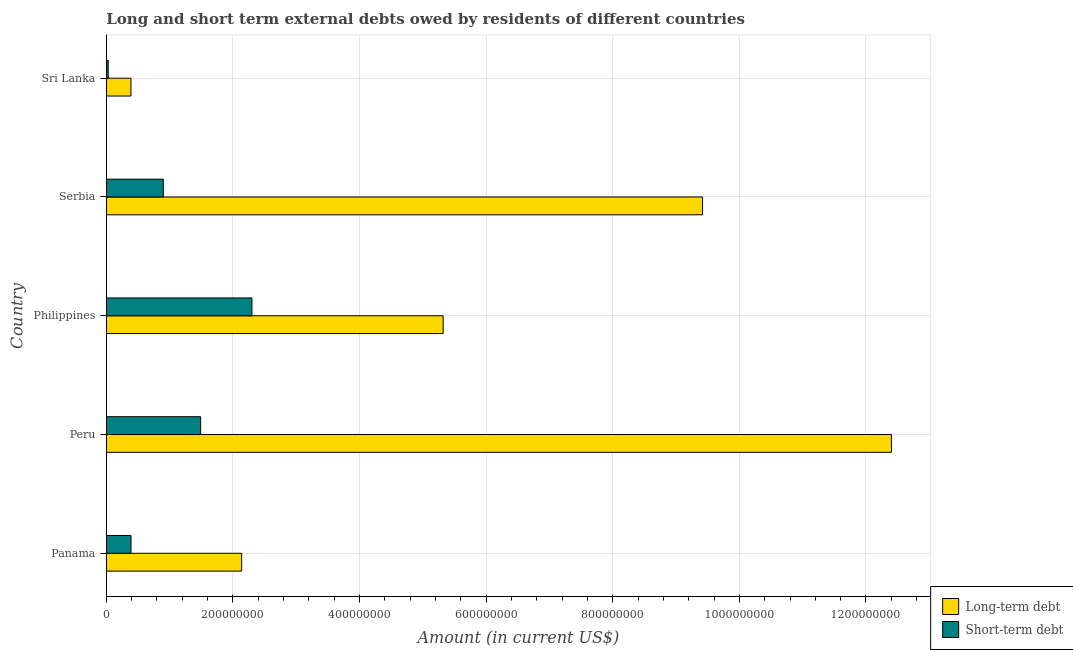How many groups of bars are there?
Your response must be concise. 5. How many bars are there on the 4th tick from the top?
Ensure brevity in your answer.  2. How many bars are there on the 1st tick from the bottom?
Offer a very short reply. 2. What is the label of the 1st group of bars from the top?
Give a very brief answer. Sri Lanka. In how many cases, is the number of bars for a given country not equal to the number of legend labels?
Provide a succinct answer. 0. What is the long-term debts owed by residents in Serbia?
Ensure brevity in your answer.  9.42e+08. Across all countries, what is the maximum long-term debts owed by residents?
Provide a short and direct response. 1.24e+09. Across all countries, what is the minimum long-term debts owed by residents?
Your answer should be very brief. 3.89e+07. In which country was the short-term debts owed by residents minimum?
Give a very brief answer. Sri Lanka. What is the total short-term debts owed by residents in the graph?
Give a very brief answer. 5.11e+08. What is the difference between the long-term debts owed by residents in Panama and that in Philippines?
Your answer should be very brief. -3.18e+08. What is the difference between the long-term debts owed by residents in Panama and the short-term debts owed by residents in Philippines?
Your answer should be very brief. -1.63e+07. What is the average short-term debts owed by residents per country?
Provide a succinct answer. 1.02e+08. What is the difference between the long-term debts owed by residents and short-term debts owed by residents in Philippines?
Provide a succinct answer. 3.02e+08. What is the ratio of the long-term debts owed by residents in Philippines to that in Serbia?
Keep it short and to the point. 0.56. What is the difference between the highest and the second highest long-term debts owed by residents?
Keep it short and to the point. 2.98e+08. What is the difference between the highest and the lowest short-term debts owed by residents?
Provide a succinct answer. 2.27e+08. In how many countries, is the long-term debts owed by residents greater than the average long-term debts owed by residents taken over all countries?
Provide a succinct answer. 2. Is the sum of the short-term debts owed by residents in Peru and Philippines greater than the maximum long-term debts owed by residents across all countries?
Make the answer very short. No. What does the 1st bar from the top in Sri Lanka represents?
Ensure brevity in your answer.  Short-term debt. What does the 2nd bar from the bottom in Panama represents?
Ensure brevity in your answer.  Short-term debt. Are all the bars in the graph horizontal?
Provide a succinct answer. Yes. How many countries are there in the graph?
Offer a terse response. 5. Are the values on the major ticks of X-axis written in scientific E-notation?
Keep it short and to the point. No. Does the graph contain grids?
Your response must be concise. Yes. How are the legend labels stacked?
Offer a very short reply. Vertical. What is the title of the graph?
Your answer should be very brief. Long and short term external debts owed by residents of different countries. What is the Amount (in current US$) in Long-term debt in Panama?
Your answer should be compact. 2.14e+08. What is the Amount (in current US$) of Short-term debt in Panama?
Your answer should be very brief. 3.90e+07. What is the Amount (in current US$) in Long-term debt in Peru?
Give a very brief answer. 1.24e+09. What is the Amount (in current US$) of Short-term debt in Peru?
Your answer should be very brief. 1.49e+08. What is the Amount (in current US$) of Long-term debt in Philippines?
Ensure brevity in your answer.  5.32e+08. What is the Amount (in current US$) in Short-term debt in Philippines?
Your response must be concise. 2.30e+08. What is the Amount (in current US$) in Long-term debt in Serbia?
Offer a very short reply. 9.42e+08. What is the Amount (in current US$) of Short-term debt in Serbia?
Your response must be concise. 9.00e+07. What is the Amount (in current US$) in Long-term debt in Sri Lanka?
Your response must be concise. 3.89e+07. What is the Amount (in current US$) in Short-term debt in Sri Lanka?
Make the answer very short. 3.00e+06. Across all countries, what is the maximum Amount (in current US$) of Long-term debt?
Your answer should be very brief. 1.24e+09. Across all countries, what is the maximum Amount (in current US$) of Short-term debt?
Give a very brief answer. 2.30e+08. Across all countries, what is the minimum Amount (in current US$) of Long-term debt?
Make the answer very short. 3.89e+07. Across all countries, what is the minimum Amount (in current US$) of Short-term debt?
Ensure brevity in your answer.  3.00e+06. What is the total Amount (in current US$) in Long-term debt in the graph?
Your response must be concise. 2.97e+09. What is the total Amount (in current US$) in Short-term debt in the graph?
Your answer should be compact. 5.11e+08. What is the difference between the Amount (in current US$) of Long-term debt in Panama and that in Peru?
Make the answer very short. -1.03e+09. What is the difference between the Amount (in current US$) in Short-term debt in Panama and that in Peru?
Your answer should be very brief. -1.10e+08. What is the difference between the Amount (in current US$) of Long-term debt in Panama and that in Philippines?
Your response must be concise. -3.18e+08. What is the difference between the Amount (in current US$) in Short-term debt in Panama and that in Philippines?
Provide a short and direct response. -1.91e+08. What is the difference between the Amount (in current US$) of Long-term debt in Panama and that in Serbia?
Provide a succinct answer. -7.28e+08. What is the difference between the Amount (in current US$) in Short-term debt in Panama and that in Serbia?
Keep it short and to the point. -5.10e+07. What is the difference between the Amount (in current US$) in Long-term debt in Panama and that in Sri Lanka?
Keep it short and to the point. 1.75e+08. What is the difference between the Amount (in current US$) in Short-term debt in Panama and that in Sri Lanka?
Your answer should be compact. 3.60e+07. What is the difference between the Amount (in current US$) of Long-term debt in Peru and that in Philippines?
Make the answer very short. 7.08e+08. What is the difference between the Amount (in current US$) in Short-term debt in Peru and that in Philippines?
Provide a succinct answer. -8.10e+07. What is the difference between the Amount (in current US$) in Long-term debt in Peru and that in Serbia?
Provide a succinct answer. 2.98e+08. What is the difference between the Amount (in current US$) in Short-term debt in Peru and that in Serbia?
Keep it short and to the point. 5.90e+07. What is the difference between the Amount (in current US$) of Long-term debt in Peru and that in Sri Lanka?
Make the answer very short. 1.20e+09. What is the difference between the Amount (in current US$) in Short-term debt in Peru and that in Sri Lanka?
Make the answer very short. 1.46e+08. What is the difference between the Amount (in current US$) of Long-term debt in Philippines and that in Serbia?
Your answer should be very brief. -4.10e+08. What is the difference between the Amount (in current US$) in Short-term debt in Philippines and that in Serbia?
Offer a terse response. 1.40e+08. What is the difference between the Amount (in current US$) of Long-term debt in Philippines and that in Sri Lanka?
Your answer should be very brief. 4.93e+08. What is the difference between the Amount (in current US$) of Short-term debt in Philippines and that in Sri Lanka?
Provide a succinct answer. 2.27e+08. What is the difference between the Amount (in current US$) of Long-term debt in Serbia and that in Sri Lanka?
Your answer should be compact. 9.03e+08. What is the difference between the Amount (in current US$) in Short-term debt in Serbia and that in Sri Lanka?
Keep it short and to the point. 8.70e+07. What is the difference between the Amount (in current US$) of Long-term debt in Panama and the Amount (in current US$) of Short-term debt in Peru?
Give a very brief answer. 6.47e+07. What is the difference between the Amount (in current US$) in Long-term debt in Panama and the Amount (in current US$) in Short-term debt in Philippines?
Make the answer very short. -1.63e+07. What is the difference between the Amount (in current US$) of Long-term debt in Panama and the Amount (in current US$) of Short-term debt in Serbia?
Offer a terse response. 1.24e+08. What is the difference between the Amount (in current US$) in Long-term debt in Panama and the Amount (in current US$) in Short-term debt in Sri Lanka?
Offer a terse response. 2.11e+08. What is the difference between the Amount (in current US$) of Long-term debt in Peru and the Amount (in current US$) of Short-term debt in Philippines?
Give a very brief answer. 1.01e+09. What is the difference between the Amount (in current US$) in Long-term debt in Peru and the Amount (in current US$) in Short-term debt in Serbia?
Provide a succinct answer. 1.15e+09. What is the difference between the Amount (in current US$) in Long-term debt in Peru and the Amount (in current US$) in Short-term debt in Sri Lanka?
Your answer should be very brief. 1.24e+09. What is the difference between the Amount (in current US$) in Long-term debt in Philippines and the Amount (in current US$) in Short-term debt in Serbia?
Give a very brief answer. 4.42e+08. What is the difference between the Amount (in current US$) in Long-term debt in Philippines and the Amount (in current US$) in Short-term debt in Sri Lanka?
Your answer should be compact. 5.29e+08. What is the difference between the Amount (in current US$) of Long-term debt in Serbia and the Amount (in current US$) of Short-term debt in Sri Lanka?
Offer a very short reply. 9.39e+08. What is the average Amount (in current US$) of Long-term debt per country?
Keep it short and to the point. 5.93e+08. What is the average Amount (in current US$) of Short-term debt per country?
Provide a short and direct response. 1.02e+08. What is the difference between the Amount (in current US$) of Long-term debt and Amount (in current US$) of Short-term debt in Panama?
Provide a succinct answer. 1.75e+08. What is the difference between the Amount (in current US$) of Long-term debt and Amount (in current US$) of Short-term debt in Peru?
Your answer should be compact. 1.09e+09. What is the difference between the Amount (in current US$) in Long-term debt and Amount (in current US$) in Short-term debt in Philippines?
Your answer should be compact. 3.02e+08. What is the difference between the Amount (in current US$) in Long-term debt and Amount (in current US$) in Short-term debt in Serbia?
Provide a short and direct response. 8.52e+08. What is the difference between the Amount (in current US$) of Long-term debt and Amount (in current US$) of Short-term debt in Sri Lanka?
Your answer should be compact. 3.59e+07. What is the ratio of the Amount (in current US$) in Long-term debt in Panama to that in Peru?
Provide a succinct answer. 0.17. What is the ratio of the Amount (in current US$) of Short-term debt in Panama to that in Peru?
Offer a terse response. 0.26. What is the ratio of the Amount (in current US$) in Long-term debt in Panama to that in Philippines?
Offer a terse response. 0.4. What is the ratio of the Amount (in current US$) in Short-term debt in Panama to that in Philippines?
Your answer should be very brief. 0.17. What is the ratio of the Amount (in current US$) in Long-term debt in Panama to that in Serbia?
Give a very brief answer. 0.23. What is the ratio of the Amount (in current US$) in Short-term debt in Panama to that in Serbia?
Offer a terse response. 0.43. What is the ratio of the Amount (in current US$) of Long-term debt in Panama to that in Sri Lanka?
Your answer should be very brief. 5.5. What is the ratio of the Amount (in current US$) in Short-term debt in Panama to that in Sri Lanka?
Offer a very short reply. 13. What is the ratio of the Amount (in current US$) of Long-term debt in Peru to that in Philippines?
Give a very brief answer. 2.33. What is the ratio of the Amount (in current US$) in Short-term debt in Peru to that in Philippines?
Your response must be concise. 0.65. What is the ratio of the Amount (in current US$) in Long-term debt in Peru to that in Serbia?
Your answer should be very brief. 1.32. What is the ratio of the Amount (in current US$) of Short-term debt in Peru to that in Serbia?
Ensure brevity in your answer.  1.66. What is the ratio of the Amount (in current US$) in Long-term debt in Peru to that in Sri Lanka?
Your response must be concise. 31.89. What is the ratio of the Amount (in current US$) of Short-term debt in Peru to that in Sri Lanka?
Ensure brevity in your answer.  49.67. What is the ratio of the Amount (in current US$) in Long-term debt in Philippines to that in Serbia?
Provide a short and direct response. 0.56. What is the ratio of the Amount (in current US$) in Short-term debt in Philippines to that in Serbia?
Offer a very short reply. 2.56. What is the ratio of the Amount (in current US$) of Long-term debt in Philippines to that in Sri Lanka?
Provide a succinct answer. 13.68. What is the ratio of the Amount (in current US$) of Short-term debt in Philippines to that in Sri Lanka?
Keep it short and to the point. 76.67. What is the ratio of the Amount (in current US$) in Long-term debt in Serbia to that in Sri Lanka?
Keep it short and to the point. 24.22. What is the ratio of the Amount (in current US$) of Short-term debt in Serbia to that in Sri Lanka?
Your response must be concise. 30. What is the difference between the highest and the second highest Amount (in current US$) in Long-term debt?
Offer a terse response. 2.98e+08. What is the difference between the highest and the second highest Amount (in current US$) in Short-term debt?
Provide a succinct answer. 8.10e+07. What is the difference between the highest and the lowest Amount (in current US$) of Long-term debt?
Ensure brevity in your answer.  1.20e+09. What is the difference between the highest and the lowest Amount (in current US$) of Short-term debt?
Provide a succinct answer. 2.27e+08. 